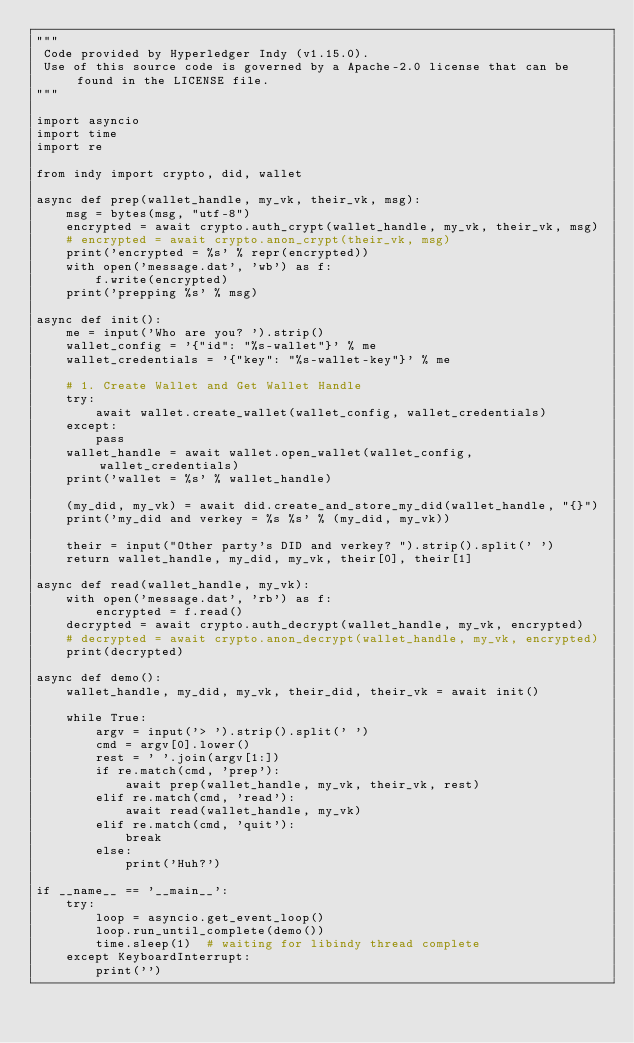Convert code to text. <code><loc_0><loc_0><loc_500><loc_500><_Python_>"""
 Code provided by Hyperledger Indy (v1.15.0).
 Use of this source code is governed by a Apache-2.0 license that can be found in the LICENSE file.
"""

import asyncio
import time
import re

from indy import crypto, did, wallet

async def prep(wallet_handle, my_vk, their_vk, msg):
    msg = bytes(msg, "utf-8")
    encrypted = await crypto.auth_crypt(wallet_handle, my_vk, their_vk, msg)
    # encrypted = await crypto.anon_crypt(their_vk, msg)
    print('encrypted = %s' % repr(encrypted))
    with open('message.dat', 'wb') as f:
        f.write(encrypted)
    print('prepping %s' % msg)

async def init():
    me = input('Who are you? ').strip()
    wallet_config = '{"id": "%s-wallet"}' % me
    wallet_credentials = '{"key": "%s-wallet-key"}' % me

    # 1. Create Wallet and Get Wallet Handle
    try:
        await wallet.create_wallet(wallet_config, wallet_credentials)
    except:
        pass
    wallet_handle = await wallet.open_wallet(wallet_config, wallet_credentials)
    print('wallet = %s' % wallet_handle)

    (my_did, my_vk) = await did.create_and_store_my_did(wallet_handle, "{}")
    print('my_did and verkey = %s %s' % (my_did, my_vk))

    their = input("Other party's DID and verkey? ").strip().split(' ')
    return wallet_handle, my_did, my_vk, their[0], their[1]

async def read(wallet_handle, my_vk):
    with open('message.dat', 'rb') as f:
        encrypted = f.read()
    decrypted = await crypto.auth_decrypt(wallet_handle, my_vk, encrypted)
    # decrypted = await crypto.anon_decrypt(wallet_handle, my_vk, encrypted)
    print(decrypted)

async def demo():
    wallet_handle, my_did, my_vk, their_did, their_vk = await init()

    while True:
        argv = input('> ').strip().split(' ')
        cmd = argv[0].lower()
        rest = ' '.join(argv[1:])
        if re.match(cmd, 'prep'):
            await prep(wallet_handle, my_vk, their_vk, rest)
        elif re.match(cmd, 'read'):
            await read(wallet_handle, my_vk)
        elif re.match(cmd, 'quit'):
            break
        else:
            print('Huh?')

if __name__ == '__main__':
    try:
        loop = asyncio.get_event_loop()
        loop.run_until_complete(demo())
        time.sleep(1)  # waiting for libindy thread complete
    except KeyboardInterrupt:
        print('')</code> 